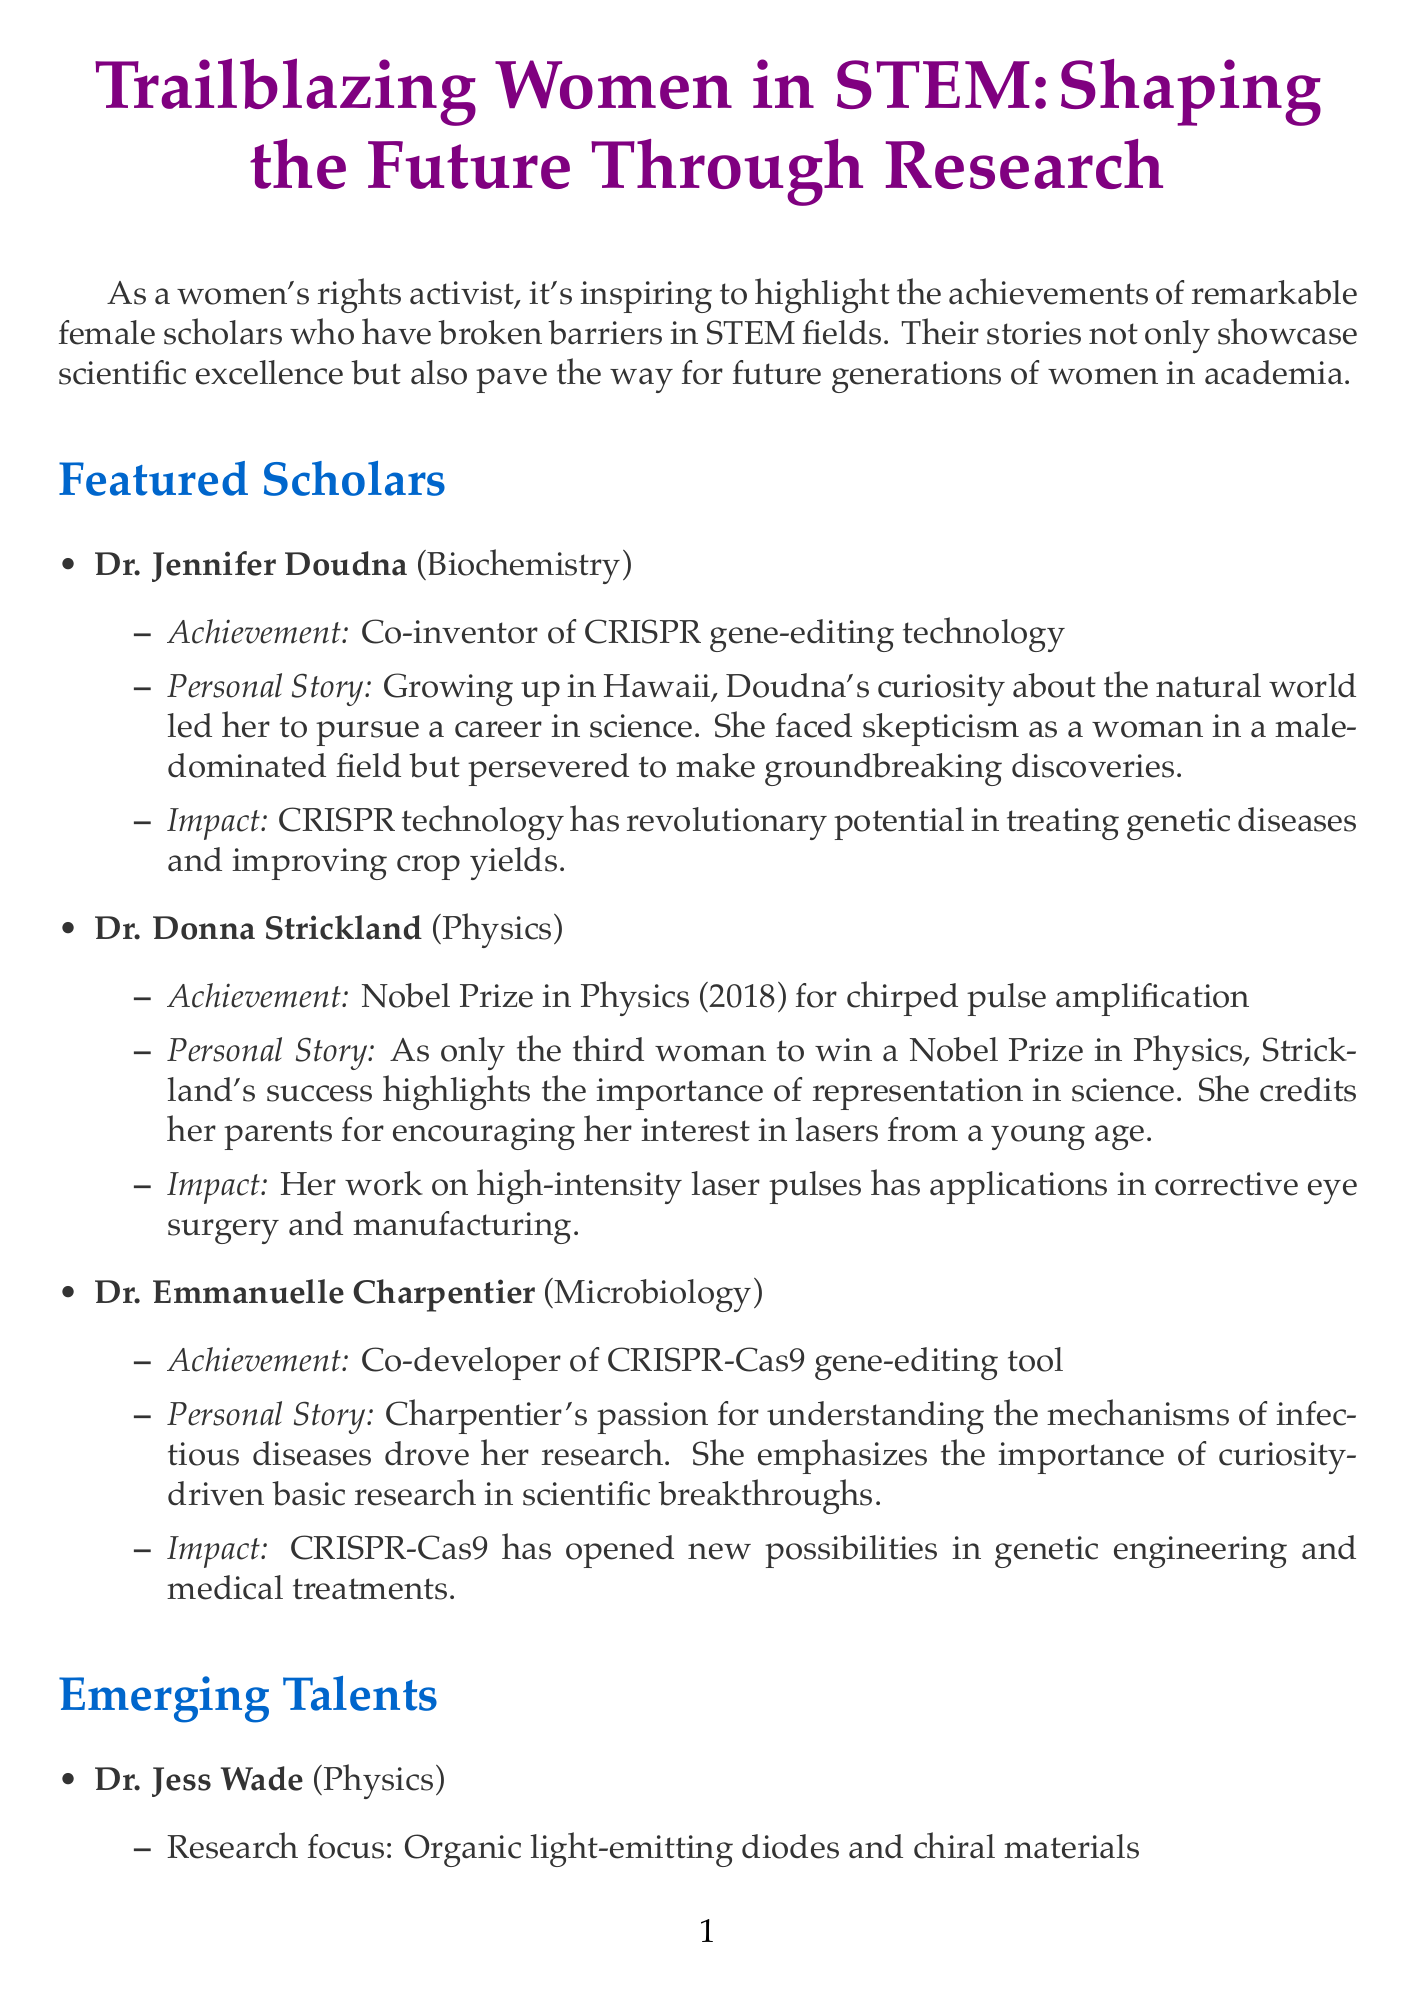What is the title of the newsletter? The title of the newsletter is clearly stated at the top.
Answer: Trailblazing Women in STEM: Shaping the Future Through Research Who is the co-inventor of CRISPR gene-editing technology? Among the featured scholars, Jennifer Doudna is recognized for this achievement.
Answer: Dr. Jennifer Doudna What year did Dr. Donna Strickland win the Nobel Prize in Physics? The document mentions Dr. Strickland's Nobel Prize win and specifies the year.
Answer: 2018 Which field does Dr. Emmanuelle Charpentier specialize in? The field of specialization for each scholar is listed.
Answer: Microbiology What is the research focus of Dr. Jess Wade? The newsletter details the research focus of emerging talents.
Answer: Organic light-emitting diodes and chiral materials What ongoing issue related to women in academia is mentioned? The document lists challenges faced by women in academia.
Answer: Gender pay gap in academic positions What is one positive development in women-led research mentioned? The document outlines recent advances for women in STEM.
Answer: Increased funding for women-led research projects Which organization is recommended for supporting women in STEM? The call to action lists specific organizations to support.
Answer: Association for Women in Science (AWIS) 